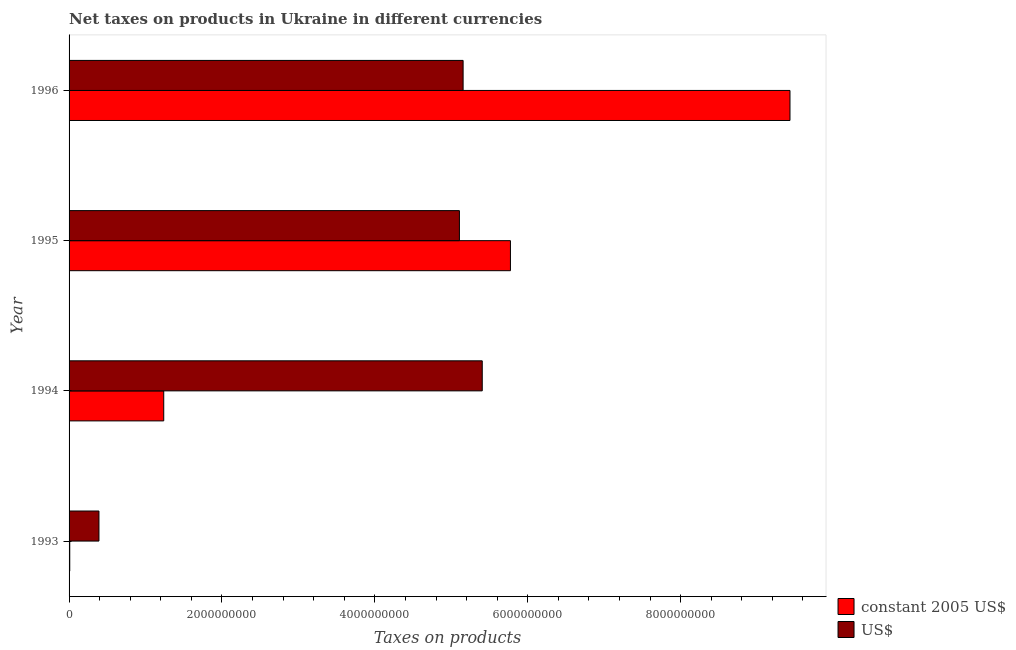Are the number of bars per tick equal to the number of legend labels?
Keep it short and to the point. Yes. How many bars are there on the 3rd tick from the top?
Ensure brevity in your answer.  2. How many bars are there on the 1st tick from the bottom?
Keep it short and to the point. 2. What is the label of the 1st group of bars from the top?
Your answer should be compact. 1996. What is the net taxes in us$ in 1993?
Make the answer very short. 3.91e+08. Across all years, what is the maximum net taxes in constant 2005 us$?
Your answer should be compact. 9.43e+09. Across all years, what is the minimum net taxes in constant 2005 us$?
Keep it short and to the point. 8.83e+06. What is the total net taxes in constant 2005 us$ in the graph?
Your response must be concise. 1.65e+1. What is the difference between the net taxes in constant 2005 us$ in 1993 and that in 1996?
Provide a short and direct response. -9.42e+09. What is the difference between the net taxes in constant 2005 us$ in 1996 and the net taxes in us$ in 1994?
Your response must be concise. 4.03e+09. What is the average net taxes in us$ per year?
Your answer should be very brief. 4.01e+09. In the year 1993, what is the difference between the net taxes in us$ and net taxes in constant 2005 us$?
Ensure brevity in your answer.  3.82e+08. What is the ratio of the net taxes in constant 2005 us$ in 1993 to that in 1996?
Ensure brevity in your answer.  0. What is the difference between the highest and the second highest net taxes in us$?
Offer a very short reply. 2.50e+08. What is the difference between the highest and the lowest net taxes in constant 2005 us$?
Give a very brief answer. 9.42e+09. Is the sum of the net taxes in constant 2005 us$ in 1994 and 1995 greater than the maximum net taxes in us$ across all years?
Provide a short and direct response. Yes. What does the 2nd bar from the top in 1993 represents?
Provide a short and direct response. Constant 2005 us$. What does the 1st bar from the bottom in 1995 represents?
Your response must be concise. Constant 2005 us$. Are all the bars in the graph horizontal?
Offer a very short reply. Yes. What is the difference between two consecutive major ticks on the X-axis?
Keep it short and to the point. 2.00e+09. Are the values on the major ticks of X-axis written in scientific E-notation?
Your answer should be very brief. No. Does the graph contain any zero values?
Offer a terse response. No. Does the graph contain grids?
Give a very brief answer. No. Where does the legend appear in the graph?
Your response must be concise. Bottom right. How many legend labels are there?
Provide a short and direct response. 2. How are the legend labels stacked?
Give a very brief answer. Vertical. What is the title of the graph?
Give a very brief answer. Net taxes on products in Ukraine in different currencies. Does "Forest" appear as one of the legend labels in the graph?
Give a very brief answer. No. What is the label or title of the X-axis?
Your answer should be very brief. Taxes on products. What is the label or title of the Y-axis?
Make the answer very short. Year. What is the Taxes on products of constant 2005 US$ in 1993?
Your response must be concise. 8.83e+06. What is the Taxes on products in US$ in 1993?
Provide a succinct answer. 3.91e+08. What is the Taxes on products of constant 2005 US$ in 1994?
Keep it short and to the point. 1.24e+09. What is the Taxes on products of US$ in 1994?
Provide a short and direct response. 5.40e+09. What is the Taxes on products in constant 2005 US$ in 1995?
Your answer should be very brief. 5.77e+09. What is the Taxes on products of US$ in 1995?
Ensure brevity in your answer.  5.11e+09. What is the Taxes on products of constant 2005 US$ in 1996?
Provide a succinct answer. 9.43e+09. What is the Taxes on products of US$ in 1996?
Provide a short and direct response. 5.15e+09. Across all years, what is the maximum Taxes on products of constant 2005 US$?
Ensure brevity in your answer.  9.43e+09. Across all years, what is the maximum Taxes on products in US$?
Ensure brevity in your answer.  5.40e+09. Across all years, what is the minimum Taxes on products in constant 2005 US$?
Offer a very short reply. 8.83e+06. Across all years, what is the minimum Taxes on products of US$?
Provide a succinct answer. 3.91e+08. What is the total Taxes on products in constant 2005 US$ in the graph?
Offer a terse response. 1.65e+1. What is the total Taxes on products of US$ in the graph?
Your response must be concise. 1.61e+1. What is the difference between the Taxes on products in constant 2005 US$ in 1993 and that in 1994?
Your answer should be compact. -1.23e+09. What is the difference between the Taxes on products of US$ in 1993 and that in 1994?
Give a very brief answer. -5.01e+09. What is the difference between the Taxes on products in constant 2005 US$ in 1993 and that in 1995?
Offer a very short reply. -5.76e+09. What is the difference between the Taxes on products in US$ in 1993 and that in 1995?
Offer a terse response. -4.72e+09. What is the difference between the Taxes on products in constant 2005 US$ in 1993 and that in 1996?
Offer a terse response. -9.42e+09. What is the difference between the Taxes on products in US$ in 1993 and that in 1996?
Your answer should be very brief. -4.76e+09. What is the difference between the Taxes on products in constant 2005 US$ in 1994 and that in 1995?
Offer a very short reply. -4.54e+09. What is the difference between the Taxes on products of US$ in 1994 and that in 1995?
Your answer should be compact. 2.99e+08. What is the difference between the Taxes on products in constant 2005 US$ in 1994 and that in 1996?
Offer a terse response. -8.19e+09. What is the difference between the Taxes on products of US$ in 1994 and that in 1996?
Offer a very short reply. 2.50e+08. What is the difference between the Taxes on products in constant 2005 US$ in 1995 and that in 1996?
Offer a terse response. -3.66e+09. What is the difference between the Taxes on products of US$ in 1995 and that in 1996?
Make the answer very short. -4.83e+07. What is the difference between the Taxes on products in constant 2005 US$ in 1993 and the Taxes on products in US$ in 1994?
Offer a very short reply. -5.40e+09. What is the difference between the Taxes on products of constant 2005 US$ in 1993 and the Taxes on products of US$ in 1995?
Make the answer very short. -5.10e+09. What is the difference between the Taxes on products of constant 2005 US$ in 1993 and the Taxes on products of US$ in 1996?
Provide a short and direct response. -5.15e+09. What is the difference between the Taxes on products in constant 2005 US$ in 1994 and the Taxes on products in US$ in 1995?
Your response must be concise. -3.87e+09. What is the difference between the Taxes on products of constant 2005 US$ in 1994 and the Taxes on products of US$ in 1996?
Give a very brief answer. -3.92e+09. What is the difference between the Taxes on products in constant 2005 US$ in 1995 and the Taxes on products in US$ in 1996?
Give a very brief answer. 6.19e+08. What is the average Taxes on products of constant 2005 US$ per year?
Give a very brief answer. 4.11e+09. What is the average Taxes on products in US$ per year?
Offer a very short reply. 4.01e+09. In the year 1993, what is the difference between the Taxes on products in constant 2005 US$ and Taxes on products in US$?
Ensure brevity in your answer.  -3.82e+08. In the year 1994, what is the difference between the Taxes on products of constant 2005 US$ and Taxes on products of US$?
Offer a terse response. -4.17e+09. In the year 1995, what is the difference between the Taxes on products of constant 2005 US$ and Taxes on products of US$?
Provide a short and direct response. 6.67e+08. In the year 1996, what is the difference between the Taxes on products of constant 2005 US$ and Taxes on products of US$?
Your response must be concise. 4.28e+09. What is the ratio of the Taxes on products in constant 2005 US$ in 1993 to that in 1994?
Keep it short and to the point. 0.01. What is the ratio of the Taxes on products in US$ in 1993 to that in 1994?
Your answer should be very brief. 0.07. What is the ratio of the Taxes on products in constant 2005 US$ in 1993 to that in 1995?
Make the answer very short. 0. What is the ratio of the Taxes on products of US$ in 1993 to that in 1995?
Keep it short and to the point. 0.08. What is the ratio of the Taxes on products of constant 2005 US$ in 1993 to that in 1996?
Give a very brief answer. 0. What is the ratio of the Taxes on products in US$ in 1993 to that in 1996?
Your answer should be very brief. 0.08. What is the ratio of the Taxes on products in constant 2005 US$ in 1994 to that in 1995?
Your answer should be compact. 0.21. What is the ratio of the Taxes on products of US$ in 1994 to that in 1995?
Make the answer very short. 1.06. What is the ratio of the Taxes on products of constant 2005 US$ in 1994 to that in 1996?
Keep it short and to the point. 0.13. What is the ratio of the Taxes on products in US$ in 1994 to that in 1996?
Give a very brief answer. 1.05. What is the ratio of the Taxes on products in constant 2005 US$ in 1995 to that in 1996?
Provide a succinct answer. 0.61. What is the ratio of the Taxes on products of US$ in 1995 to that in 1996?
Your response must be concise. 0.99. What is the difference between the highest and the second highest Taxes on products in constant 2005 US$?
Provide a succinct answer. 3.66e+09. What is the difference between the highest and the second highest Taxes on products of US$?
Make the answer very short. 2.50e+08. What is the difference between the highest and the lowest Taxes on products of constant 2005 US$?
Your answer should be very brief. 9.42e+09. What is the difference between the highest and the lowest Taxes on products of US$?
Keep it short and to the point. 5.01e+09. 